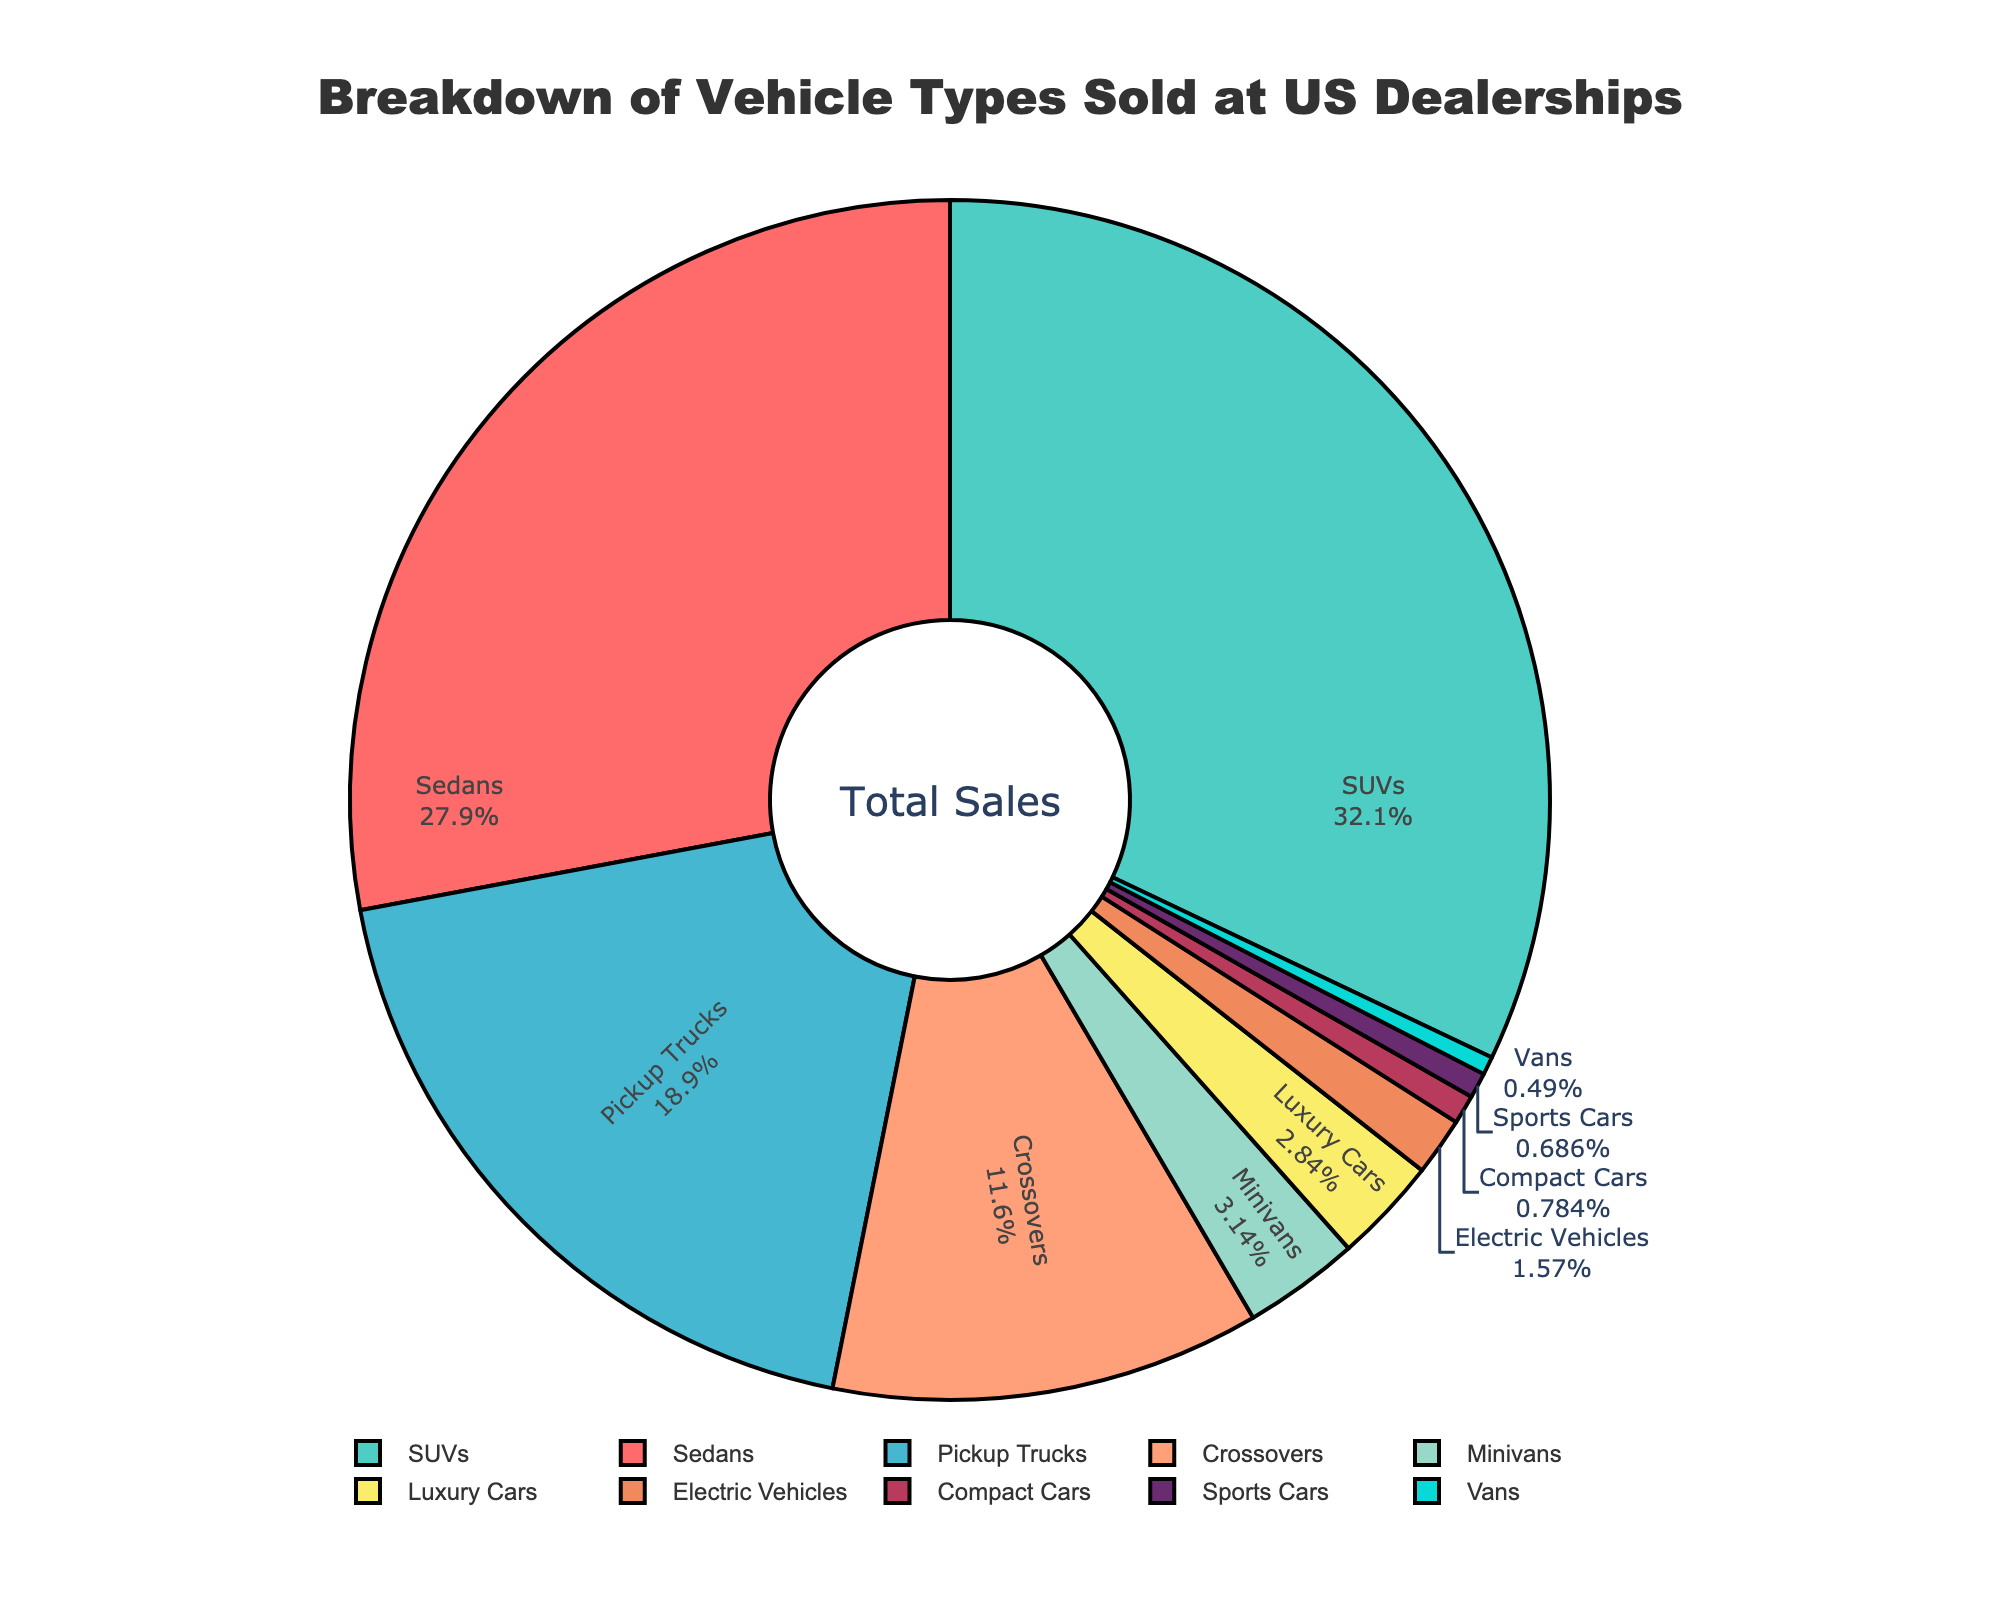What is the most sold vehicle type in US dealerships? By looking at the pie chart, we observe that SUVs occupy the largest segment, with the highest percentage of vehicle types sold: 32.7%.
Answer: SUVs Which vehicle types collectively make up more than 50% of sales? Summing the percentages of the top vehicle types: SUVs (32.7%), Sedans (28.5%), and Pickup Trucks (19.3%) gives us 32.7% + 28.5% + 19.3% = 80.5%, which is more than 50%.
Answer: SUVs, Sedans, Pickup Trucks How much larger is the percentage of SUVs sold compared to Electric Vehicles? The percentage of SUVs sold is 32.7%, and the percentage of Electric Vehicles sold is 1.6%. The difference is 32.7% - 1.6% = 31.1%.
Answer: 31.1% Which vehicle type has the smallest sales percentage, and what is that percentage? By observing the smallest segment in the pie chart, Vans have the smallest percentage of sales at 0.5% of total sales.
Answer: Vans, 0.5% What is the combined percentage of Crossovers and Minivans sold? Crossovers have a sales percentage of 11.8%, and Minivans have a sales percentage of 3.2%. Adding these together, we get 11.8% + 3.2% = 15%.
Answer: 15% How does the percentage of Sedans sold compare to the percentage of Pickup Trucks sold? Sedans have a percentage of 28.5%, whereas Pickup Trucks have a percentage of 19.3%. Thus, Sedans have a higher sales percentage by 28.5% - 19.3% = 9.2%.
Answer: Sedans have a higher percentage by 9.2% Which has a higher sales percentage: Luxury Cars or Compact Cars? Looking at the pie chart, Luxury Cars have a sales percentage of 2.9%, and Compact Cars have a sales percentage of 0.8%. Luxury Cars have a higher percentage.
Answer: Luxury Cars What is the total sales percentage for vehicle types other than SUVs? Subtract the percentage of SUVs (32.7%) from the total percentage (100%). Therefore, 100% - 32.7% equals 67.3%.
Answer: 67.3% Which vehicle types together make up less than 5% of sales? The vehicle types less than 5% are Minivans (3.2%), Luxury Cars (2.9%), Electric Vehicles (1.6%), Compact Cars (0.8%), Sports Cars (0.7%), and Vans (0.5%). Summing these: 3.2% + 2.9% + 1.6% + 0.8% + 0.7% + 0.5% = 9.7%. Therefore, individual types making up less than 5% are Electric Vehicles, Compact Cars, Sports Cars, and Vans.
Answer: Electric Vehicles, Compact Cars, Sports Cars, Vans 